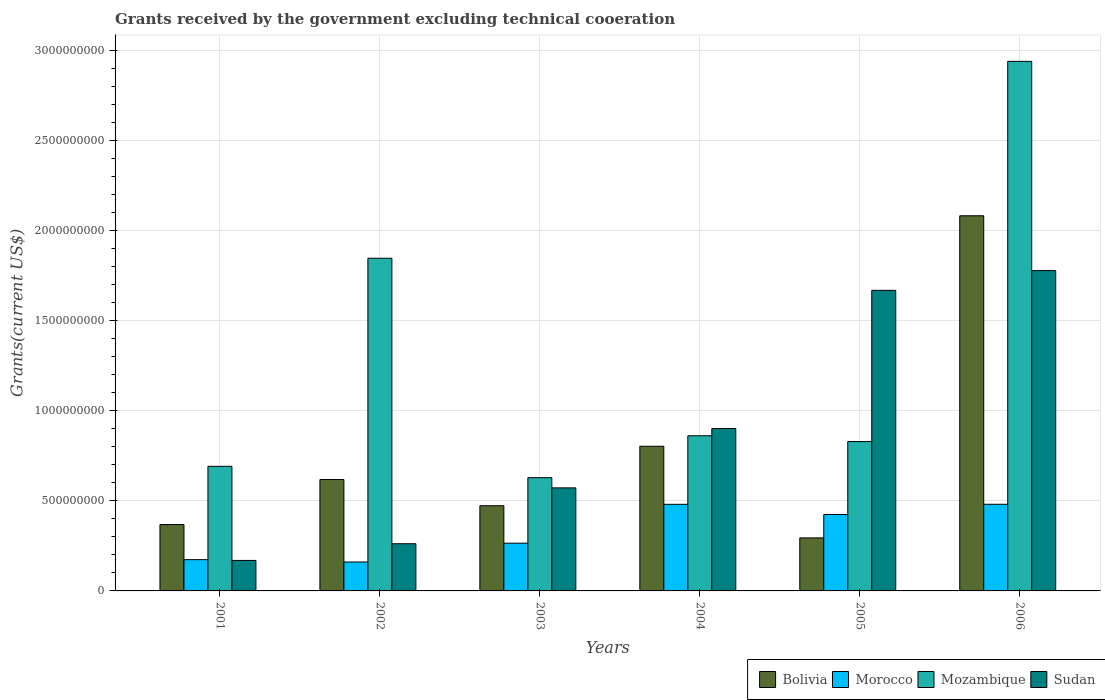How many groups of bars are there?
Your answer should be compact. 6. Are the number of bars on each tick of the X-axis equal?
Your answer should be compact. Yes. How many bars are there on the 4th tick from the right?
Provide a short and direct response. 4. What is the label of the 1st group of bars from the left?
Provide a succinct answer. 2001. In how many cases, is the number of bars for a given year not equal to the number of legend labels?
Provide a short and direct response. 0. What is the total grants received by the government in Sudan in 2005?
Give a very brief answer. 1.67e+09. Across all years, what is the maximum total grants received by the government in Mozambique?
Give a very brief answer. 2.94e+09. Across all years, what is the minimum total grants received by the government in Mozambique?
Offer a terse response. 6.28e+08. What is the total total grants received by the government in Bolivia in the graph?
Your answer should be compact. 4.64e+09. What is the difference between the total grants received by the government in Sudan in 2004 and that in 2005?
Offer a terse response. -7.67e+08. What is the difference between the total grants received by the government in Sudan in 2005 and the total grants received by the government in Mozambique in 2001?
Make the answer very short. 9.76e+08. What is the average total grants received by the government in Sudan per year?
Offer a very short reply. 8.91e+08. In the year 2003, what is the difference between the total grants received by the government in Bolivia and total grants received by the government in Sudan?
Your answer should be compact. -9.91e+07. In how many years, is the total grants received by the government in Mozambique greater than 900000000 US$?
Make the answer very short. 2. What is the ratio of the total grants received by the government in Sudan in 2002 to that in 2004?
Make the answer very short. 0.29. Is the total grants received by the government in Mozambique in 2001 less than that in 2002?
Provide a short and direct response. Yes. What is the difference between the highest and the second highest total grants received by the government in Mozambique?
Offer a very short reply. 1.09e+09. What is the difference between the highest and the lowest total grants received by the government in Mozambique?
Give a very brief answer. 2.31e+09. In how many years, is the total grants received by the government in Morocco greater than the average total grants received by the government in Morocco taken over all years?
Make the answer very short. 3. Is the sum of the total grants received by the government in Sudan in 2001 and 2003 greater than the maximum total grants received by the government in Mozambique across all years?
Provide a short and direct response. No. What does the 2nd bar from the left in 2006 represents?
Provide a short and direct response. Morocco. What does the 3rd bar from the right in 2002 represents?
Make the answer very short. Morocco. Is it the case that in every year, the sum of the total grants received by the government in Morocco and total grants received by the government in Mozambique is greater than the total grants received by the government in Sudan?
Keep it short and to the point. No. How many bars are there?
Provide a short and direct response. 24. How many years are there in the graph?
Your answer should be very brief. 6. Does the graph contain grids?
Provide a succinct answer. Yes. Where does the legend appear in the graph?
Your answer should be very brief. Bottom right. How many legend labels are there?
Offer a terse response. 4. How are the legend labels stacked?
Your answer should be very brief. Horizontal. What is the title of the graph?
Your answer should be very brief. Grants received by the government excluding technical cooeration. Does "Senegal" appear as one of the legend labels in the graph?
Keep it short and to the point. No. What is the label or title of the X-axis?
Your answer should be very brief. Years. What is the label or title of the Y-axis?
Give a very brief answer. Grants(current US$). What is the Grants(current US$) of Bolivia in 2001?
Your answer should be compact. 3.68e+08. What is the Grants(current US$) of Morocco in 2001?
Offer a terse response. 1.73e+08. What is the Grants(current US$) of Mozambique in 2001?
Provide a succinct answer. 6.91e+08. What is the Grants(current US$) of Sudan in 2001?
Your answer should be very brief. 1.69e+08. What is the Grants(current US$) in Bolivia in 2002?
Your answer should be very brief. 6.18e+08. What is the Grants(current US$) of Morocco in 2002?
Provide a short and direct response. 1.60e+08. What is the Grants(current US$) in Mozambique in 2002?
Offer a very short reply. 1.85e+09. What is the Grants(current US$) of Sudan in 2002?
Your answer should be very brief. 2.62e+08. What is the Grants(current US$) in Bolivia in 2003?
Offer a terse response. 4.73e+08. What is the Grants(current US$) of Morocco in 2003?
Give a very brief answer. 2.65e+08. What is the Grants(current US$) of Mozambique in 2003?
Provide a short and direct response. 6.28e+08. What is the Grants(current US$) in Sudan in 2003?
Make the answer very short. 5.72e+08. What is the Grants(current US$) in Bolivia in 2004?
Offer a terse response. 8.03e+08. What is the Grants(current US$) in Morocco in 2004?
Make the answer very short. 4.80e+08. What is the Grants(current US$) in Mozambique in 2004?
Make the answer very short. 8.61e+08. What is the Grants(current US$) in Sudan in 2004?
Provide a short and direct response. 9.01e+08. What is the Grants(current US$) of Bolivia in 2005?
Keep it short and to the point. 2.94e+08. What is the Grants(current US$) of Morocco in 2005?
Offer a terse response. 4.24e+08. What is the Grants(current US$) in Mozambique in 2005?
Your response must be concise. 8.29e+08. What is the Grants(current US$) in Sudan in 2005?
Your answer should be very brief. 1.67e+09. What is the Grants(current US$) in Bolivia in 2006?
Offer a terse response. 2.08e+09. What is the Grants(current US$) in Morocco in 2006?
Your answer should be very brief. 4.81e+08. What is the Grants(current US$) in Mozambique in 2006?
Offer a terse response. 2.94e+09. What is the Grants(current US$) in Sudan in 2006?
Ensure brevity in your answer.  1.78e+09. Across all years, what is the maximum Grants(current US$) of Bolivia?
Keep it short and to the point. 2.08e+09. Across all years, what is the maximum Grants(current US$) in Morocco?
Give a very brief answer. 4.81e+08. Across all years, what is the maximum Grants(current US$) in Mozambique?
Offer a very short reply. 2.94e+09. Across all years, what is the maximum Grants(current US$) in Sudan?
Offer a very short reply. 1.78e+09. Across all years, what is the minimum Grants(current US$) in Bolivia?
Offer a very short reply. 2.94e+08. Across all years, what is the minimum Grants(current US$) of Morocco?
Your answer should be compact. 1.60e+08. Across all years, what is the minimum Grants(current US$) of Mozambique?
Make the answer very short. 6.28e+08. Across all years, what is the minimum Grants(current US$) in Sudan?
Your response must be concise. 1.69e+08. What is the total Grants(current US$) of Bolivia in the graph?
Offer a very short reply. 4.64e+09. What is the total Grants(current US$) of Morocco in the graph?
Your response must be concise. 1.98e+09. What is the total Grants(current US$) of Mozambique in the graph?
Offer a terse response. 7.79e+09. What is the total Grants(current US$) in Sudan in the graph?
Your answer should be compact. 5.35e+09. What is the difference between the Grants(current US$) in Bolivia in 2001 and that in 2002?
Your response must be concise. -2.50e+08. What is the difference between the Grants(current US$) in Morocco in 2001 and that in 2002?
Your answer should be compact. 1.30e+07. What is the difference between the Grants(current US$) in Mozambique in 2001 and that in 2002?
Offer a terse response. -1.15e+09. What is the difference between the Grants(current US$) in Sudan in 2001 and that in 2002?
Ensure brevity in your answer.  -9.25e+07. What is the difference between the Grants(current US$) in Bolivia in 2001 and that in 2003?
Keep it short and to the point. -1.05e+08. What is the difference between the Grants(current US$) of Morocco in 2001 and that in 2003?
Provide a short and direct response. -9.14e+07. What is the difference between the Grants(current US$) of Mozambique in 2001 and that in 2003?
Offer a very short reply. 6.31e+07. What is the difference between the Grants(current US$) of Sudan in 2001 and that in 2003?
Give a very brief answer. -4.03e+08. What is the difference between the Grants(current US$) in Bolivia in 2001 and that in 2004?
Offer a terse response. -4.34e+08. What is the difference between the Grants(current US$) of Morocco in 2001 and that in 2004?
Keep it short and to the point. -3.07e+08. What is the difference between the Grants(current US$) of Mozambique in 2001 and that in 2004?
Make the answer very short. -1.70e+08. What is the difference between the Grants(current US$) of Sudan in 2001 and that in 2004?
Offer a very short reply. -7.32e+08. What is the difference between the Grants(current US$) in Bolivia in 2001 and that in 2005?
Your answer should be very brief. 7.40e+07. What is the difference between the Grants(current US$) of Morocco in 2001 and that in 2005?
Give a very brief answer. -2.51e+08. What is the difference between the Grants(current US$) of Mozambique in 2001 and that in 2005?
Give a very brief answer. -1.37e+08. What is the difference between the Grants(current US$) in Sudan in 2001 and that in 2005?
Give a very brief answer. -1.50e+09. What is the difference between the Grants(current US$) in Bolivia in 2001 and that in 2006?
Your answer should be very brief. -1.71e+09. What is the difference between the Grants(current US$) of Morocco in 2001 and that in 2006?
Offer a terse response. -3.07e+08. What is the difference between the Grants(current US$) in Mozambique in 2001 and that in 2006?
Give a very brief answer. -2.25e+09. What is the difference between the Grants(current US$) in Sudan in 2001 and that in 2006?
Offer a very short reply. -1.61e+09. What is the difference between the Grants(current US$) of Bolivia in 2002 and that in 2003?
Keep it short and to the point. 1.45e+08. What is the difference between the Grants(current US$) of Morocco in 2002 and that in 2003?
Offer a terse response. -1.04e+08. What is the difference between the Grants(current US$) of Mozambique in 2002 and that in 2003?
Provide a short and direct response. 1.22e+09. What is the difference between the Grants(current US$) of Sudan in 2002 and that in 2003?
Give a very brief answer. -3.10e+08. What is the difference between the Grants(current US$) in Bolivia in 2002 and that in 2004?
Offer a terse response. -1.85e+08. What is the difference between the Grants(current US$) in Morocco in 2002 and that in 2004?
Your response must be concise. -3.20e+08. What is the difference between the Grants(current US$) of Mozambique in 2002 and that in 2004?
Offer a very short reply. 9.85e+08. What is the difference between the Grants(current US$) of Sudan in 2002 and that in 2004?
Provide a short and direct response. -6.39e+08. What is the difference between the Grants(current US$) in Bolivia in 2002 and that in 2005?
Offer a terse response. 3.24e+08. What is the difference between the Grants(current US$) of Morocco in 2002 and that in 2005?
Offer a very short reply. -2.64e+08. What is the difference between the Grants(current US$) in Mozambique in 2002 and that in 2005?
Your answer should be very brief. 1.02e+09. What is the difference between the Grants(current US$) of Sudan in 2002 and that in 2005?
Give a very brief answer. -1.41e+09. What is the difference between the Grants(current US$) of Bolivia in 2002 and that in 2006?
Ensure brevity in your answer.  -1.46e+09. What is the difference between the Grants(current US$) in Morocco in 2002 and that in 2006?
Provide a short and direct response. -3.20e+08. What is the difference between the Grants(current US$) in Mozambique in 2002 and that in 2006?
Keep it short and to the point. -1.09e+09. What is the difference between the Grants(current US$) of Sudan in 2002 and that in 2006?
Keep it short and to the point. -1.52e+09. What is the difference between the Grants(current US$) in Bolivia in 2003 and that in 2004?
Give a very brief answer. -3.30e+08. What is the difference between the Grants(current US$) of Morocco in 2003 and that in 2004?
Your answer should be compact. -2.16e+08. What is the difference between the Grants(current US$) in Mozambique in 2003 and that in 2004?
Keep it short and to the point. -2.33e+08. What is the difference between the Grants(current US$) in Sudan in 2003 and that in 2004?
Keep it short and to the point. -3.29e+08. What is the difference between the Grants(current US$) of Bolivia in 2003 and that in 2005?
Your answer should be compact. 1.79e+08. What is the difference between the Grants(current US$) in Morocco in 2003 and that in 2005?
Offer a very short reply. -1.59e+08. What is the difference between the Grants(current US$) in Mozambique in 2003 and that in 2005?
Offer a terse response. -2.01e+08. What is the difference between the Grants(current US$) in Sudan in 2003 and that in 2005?
Provide a succinct answer. -1.10e+09. What is the difference between the Grants(current US$) in Bolivia in 2003 and that in 2006?
Give a very brief answer. -1.61e+09. What is the difference between the Grants(current US$) in Morocco in 2003 and that in 2006?
Your response must be concise. -2.16e+08. What is the difference between the Grants(current US$) in Mozambique in 2003 and that in 2006?
Offer a terse response. -2.31e+09. What is the difference between the Grants(current US$) in Sudan in 2003 and that in 2006?
Offer a terse response. -1.21e+09. What is the difference between the Grants(current US$) of Bolivia in 2004 and that in 2005?
Offer a terse response. 5.08e+08. What is the difference between the Grants(current US$) of Morocco in 2004 and that in 2005?
Make the answer very short. 5.65e+07. What is the difference between the Grants(current US$) of Mozambique in 2004 and that in 2005?
Offer a terse response. 3.22e+07. What is the difference between the Grants(current US$) of Sudan in 2004 and that in 2005?
Ensure brevity in your answer.  -7.67e+08. What is the difference between the Grants(current US$) of Bolivia in 2004 and that in 2006?
Make the answer very short. -1.28e+09. What is the difference between the Grants(current US$) in Mozambique in 2004 and that in 2006?
Your answer should be compact. -2.08e+09. What is the difference between the Grants(current US$) in Sudan in 2004 and that in 2006?
Ensure brevity in your answer.  -8.76e+08. What is the difference between the Grants(current US$) in Bolivia in 2005 and that in 2006?
Provide a short and direct response. -1.79e+09. What is the difference between the Grants(current US$) in Morocco in 2005 and that in 2006?
Your response must be concise. -5.67e+07. What is the difference between the Grants(current US$) of Mozambique in 2005 and that in 2006?
Ensure brevity in your answer.  -2.11e+09. What is the difference between the Grants(current US$) of Sudan in 2005 and that in 2006?
Offer a terse response. -1.10e+08. What is the difference between the Grants(current US$) of Bolivia in 2001 and the Grants(current US$) of Morocco in 2002?
Ensure brevity in your answer.  2.08e+08. What is the difference between the Grants(current US$) of Bolivia in 2001 and the Grants(current US$) of Mozambique in 2002?
Offer a terse response. -1.48e+09. What is the difference between the Grants(current US$) in Bolivia in 2001 and the Grants(current US$) in Sudan in 2002?
Keep it short and to the point. 1.06e+08. What is the difference between the Grants(current US$) in Morocco in 2001 and the Grants(current US$) in Mozambique in 2002?
Your answer should be very brief. -1.67e+09. What is the difference between the Grants(current US$) of Morocco in 2001 and the Grants(current US$) of Sudan in 2002?
Your answer should be compact. -8.83e+07. What is the difference between the Grants(current US$) of Mozambique in 2001 and the Grants(current US$) of Sudan in 2002?
Make the answer very short. 4.30e+08. What is the difference between the Grants(current US$) in Bolivia in 2001 and the Grants(current US$) in Morocco in 2003?
Your answer should be compact. 1.03e+08. What is the difference between the Grants(current US$) of Bolivia in 2001 and the Grants(current US$) of Mozambique in 2003?
Your response must be concise. -2.60e+08. What is the difference between the Grants(current US$) of Bolivia in 2001 and the Grants(current US$) of Sudan in 2003?
Offer a very short reply. -2.04e+08. What is the difference between the Grants(current US$) of Morocco in 2001 and the Grants(current US$) of Mozambique in 2003?
Give a very brief answer. -4.55e+08. What is the difference between the Grants(current US$) of Morocco in 2001 and the Grants(current US$) of Sudan in 2003?
Your answer should be compact. -3.98e+08. What is the difference between the Grants(current US$) of Mozambique in 2001 and the Grants(current US$) of Sudan in 2003?
Keep it short and to the point. 1.20e+08. What is the difference between the Grants(current US$) of Bolivia in 2001 and the Grants(current US$) of Morocco in 2004?
Offer a terse response. -1.12e+08. What is the difference between the Grants(current US$) of Bolivia in 2001 and the Grants(current US$) of Mozambique in 2004?
Provide a short and direct response. -4.93e+08. What is the difference between the Grants(current US$) in Bolivia in 2001 and the Grants(current US$) in Sudan in 2004?
Your answer should be compact. -5.33e+08. What is the difference between the Grants(current US$) in Morocco in 2001 and the Grants(current US$) in Mozambique in 2004?
Offer a terse response. -6.88e+08. What is the difference between the Grants(current US$) of Morocco in 2001 and the Grants(current US$) of Sudan in 2004?
Provide a succinct answer. -7.27e+08. What is the difference between the Grants(current US$) in Mozambique in 2001 and the Grants(current US$) in Sudan in 2004?
Your response must be concise. -2.10e+08. What is the difference between the Grants(current US$) in Bolivia in 2001 and the Grants(current US$) in Morocco in 2005?
Ensure brevity in your answer.  -5.58e+07. What is the difference between the Grants(current US$) of Bolivia in 2001 and the Grants(current US$) of Mozambique in 2005?
Your answer should be compact. -4.61e+08. What is the difference between the Grants(current US$) of Bolivia in 2001 and the Grants(current US$) of Sudan in 2005?
Your answer should be very brief. -1.30e+09. What is the difference between the Grants(current US$) in Morocco in 2001 and the Grants(current US$) in Mozambique in 2005?
Provide a short and direct response. -6.55e+08. What is the difference between the Grants(current US$) in Morocco in 2001 and the Grants(current US$) in Sudan in 2005?
Provide a short and direct response. -1.49e+09. What is the difference between the Grants(current US$) of Mozambique in 2001 and the Grants(current US$) of Sudan in 2005?
Offer a terse response. -9.76e+08. What is the difference between the Grants(current US$) in Bolivia in 2001 and the Grants(current US$) in Morocco in 2006?
Provide a succinct answer. -1.13e+08. What is the difference between the Grants(current US$) of Bolivia in 2001 and the Grants(current US$) of Mozambique in 2006?
Provide a short and direct response. -2.57e+09. What is the difference between the Grants(current US$) in Bolivia in 2001 and the Grants(current US$) in Sudan in 2006?
Give a very brief answer. -1.41e+09. What is the difference between the Grants(current US$) in Morocco in 2001 and the Grants(current US$) in Mozambique in 2006?
Ensure brevity in your answer.  -2.76e+09. What is the difference between the Grants(current US$) in Morocco in 2001 and the Grants(current US$) in Sudan in 2006?
Ensure brevity in your answer.  -1.60e+09. What is the difference between the Grants(current US$) of Mozambique in 2001 and the Grants(current US$) of Sudan in 2006?
Offer a very short reply. -1.09e+09. What is the difference between the Grants(current US$) of Bolivia in 2002 and the Grants(current US$) of Morocco in 2003?
Your response must be concise. 3.53e+08. What is the difference between the Grants(current US$) of Bolivia in 2002 and the Grants(current US$) of Mozambique in 2003?
Give a very brief answer. -1.02e+07. What is the difference between the Grants(current US$) in Bolivia in 2002 and the Grants(current US$) in Sudan in 2003?
Offer a terse response. 4.62e+07. What is the difference between the Grants(current US$) of Morocco in 2002 and the Grants(current US$) of Mozambique in 2003?
Your answer should be very brief. -4.68e+08. What is the difference between the Grants(current US$) in Morocco in 2002 and the Grants(current US$) in Sudan in 2003?
Your response must be concise. -4.11e+08. What is the difference between the Grants(current US$) of Mozambique in 2002 and the Grants(current US$) of Sudan in 2003?
Your answer should be compact. 1.27e+09. What is the difference between the Grants(current US$) in Bolivia in 2002 and the Grants(current US$) in Morocco in 2004?
Offer a very short reply. 1.37e+08. What is the difference between the Grants(current US$) in Bolivia in 2002 and the Grants(current US$) in Mozambique in 2004?
Your answer should be very brief. -2.43e+08. What is the difference between the Grants(current US$) of Bolivia in 2002 and the Grants(current US$) of Sudan in 2004?
Give a very brief answer. -2.83e+08. What is the difference between the Grants(current US$) of Morocco in 2002 and the Grants(current US$) of Mozambique in 2004?
Keep it short and to the point. -7.00e+08. What is the difference between the Grants(current US$) in Morocco in 2002 and the Grants(current US$) in Sudan in 2004?
Offer a terse response. -7.40e+08. What is the difference between the Grants(current US$) in Mozambique in 2002 and the Grants(current US$) in Sudan in 2004?
Keep it short and to the point. 9.45e+08. What is the difference between the Grants(current US$) in Bolivia in 2002 and the Grants(current US$) in Morocco in 2005?
Make the answer very short. 1.94e+08. What is the difference between the Grants(current US$) of Bolivia in 2002 and the Grants(current US$) of Mozambique in 2005?
Your answer should be very brief. -2.11e+08. What is the difference between the Grants(current US$) in Bolivia in 2002 and the Grants(current US$) in Sudan in 2005?
Ensure brevity in your answer.  -1.05e+09. What is the difference between the Grants(current US$) in Morocco in 2002 and the Grants(current US$) in Mozambique in 2005?
Your response must be concise. -6.68e+08. What is the difference between the Grants(current US$) of Morocco in 2002 and the Grants(current US$) of Sudan in 2005?
Offer a very short reply. -1.51e+09. What is the difference between the Grants(current US$) of Mozambique in 2002 and the Grants(current US$) of Sudan in 2005?
Your response must be concise. 1.78e+08. What is the difference between the Grants(current US$) of Bolivia in 2002 and the Grants(current US$) of Morocco in 2006?
Offer a very short reply. 1.37e+08. What is the difference between the Grants(current US$) in Bolivia in 2002 and the Grants(current US$) in Mozambique in 2006?
Provide a short and direct response. -2.32e+09. What is the difference between the Grants(current US$) in Bolivia in 2002 and the Grants(current US$) in Sudan in 2006?
Offer a terse response. -1.16e+09. What is the difference between the Grants(current US$) of Morocco in 2002 and the Grants(current US$) of Mozambique in 2006?
Your answer should be very brief. -2.78e+09. What is the difference between the Grants(current US$) in Morocco in 2002 and the Grants(current US$) in Sudan in 2006?
Offer a terse response. -1.62e+09. What is the difference between the Grants(current US$) in Mozambique in 2002 and the Grants(current US$) in Sudan in 2006?
Your answer should be very brief. 6.85e+07. What is the difference between the Grants(current US$) of Bolivia in 2003 and the Grants(current US$) of Morocco in 2004?
Keep it short and to the point. -7.77e+06. What is the difference between the Grants(current US$) in Bolivia in 2003 and the Grants(current US$) in Mozambique in 2004?
Your answer should be compact. -3.88e+08. What is the difference between the Grants(current US$) of Bolivia in 2003 and the Grants(current US$) of Sudan in 2004?
Make the answer very short. -4.28e+08. What is the difference between the Grants(current US$) in Morocco in 2003 and the Grants(current US$) in Mozambique in 2004?
Ensure brevity in your answer.  -5.96e+08. What is the difference between the Grants(current US$) of Morocco in 2003 and the Grants(current US$) of Sudan in 2004?
Make the answer very short. -6.36e+08. What is the difference between the Grants(current US$) in Mozambique in 2003 and the Grants(current US$) in Sudan in 2004?
Provide a short and direct response. -2.73e+08. What is the difference between the Grants(current US$) in Bolivia in 2003 and the Grants(current US$) in Morocco in 2005?
Make the answer very short. 4.87e+07. What is the difference between the Grants(current US$) in Bolivia in 2003 and the Grants(current US$) in Mozambique in 2005?
Make the answer very short. -3.56e+08. What is the difference between the Grants(current US$) in Bolivia in 2003 and the Grants(current US$) in Sudan in 2005?
Your response must be concise. -1.19e+09. What is the difference between the Grants(current US$) in Morocco in 2003 and the Grants(current US$) in Mozambique in 2005?
Provide a succinct answer. -5.64e+08. What is the difference between the Grants(current US$) in Morocco in 2003 and the Grants(current US$) in Sudan in 2005?
Your answer should be compact. -1.40e+09. What is the difference between the Grants(current US$) of Mozambique in 2003 and the Grants(current US$) of Sudan in 2005?
Your answer should be very brief. -1.04e+09. What is the difference between the Grants(current US$) of Bolivia in 2003 and the Grants(current US$) of Morocco in 2006?
Provide a succinct answer. -8.01e+06. What is the difference between the Grants(current US$) of Bolivia in 2003 and the Grants(current US$) of Mozambique in 2006?
Keep it short and to the point. -2.47e+09. What is the difference between the Grants(current US$) in Bolivia in 2003 and the Grants(current US$) in Sudan in 2006?
Your answer should be compact. -1.30e+09. What is the difference between the Grants(current US$) in Morocco in 2003 and the Grants(current US$) in Mozambique in 2006?
Offer a terse response. -2.67e+09. What is the difference between the Grants(current US$) in Morocco in 2003 and the Grants(current US$) in Sudan in 2006?
Your response must be concise. -1.51e+09. What is the difference between the Grants(current US$) in Mozambique in 2003 and the Grants(current US$) in Sudan in 2006?
Your answer should be very brief. -1.15e+09. What is the difference between the Grants(current US$) in Bolivia in 2004 and the Grants(current US$) in Morocco in 2005?
Provide a succinct answer. 3.79e+08. What is the difference between the Grants(current US$) of Bolivia in 2004 and the Grants(current US$) of Mozambique in 2005?
Your response must be concise. -2.61e+07. What is the difference between the Grants(current US$) in Bolivia in 2004 and the Grants(current US$) in Sudan in 2005?
Ensure brevity in your answer.  -8.65e+08. What is the difference between the Grants(current US$) in Morocco in 2004 and the Grants(current US$) in Mozambique in 2005?
Your answer should be very brief. -3.48e+08. What is the difference between the Grants(current US$) of Morocco in 2004 and the Grants(current US$) of Sudan in 2005?
Offer a terse response. -1.19e+09. What is the difference between the Grants(current US$) of Mozambique in 2004 and the Grants(current US$) of Sudan in 2005?
Provide a succinct answer. -8.07e+08. What is the difference between the Grants(current US$) in Bolivia in 2004 and the Grants(current US$) in Morocco in 2006?
Keep it short and to the point. 3.22e+08. What is the difference between the Grants(current US$) of Bolivia in 2004 and the Grants(current US$) of Mozambique in 2006?
Your response must be concise. -2.14e+09. What is the difference between the Grants(current US$) of Bolivia in 2004 and the Grants(current US$) of Sudan in 2006?
Your answer should be compact. -9.75e+08. What is the difference between the Grants(current US$) in Morocco in 2004 and the Grants(current US$) in Mozambique in 2006?
Make the answer very short. -2.46e+09. What is the difference between the Grants(current US$) in Morocco in 2004 and the Grants(current US$) in Sudan in 2006?
Offer a very short reply. -1.30e+09. What is the difference between the Grants(current US$) in Mozambique in 2004 and the Grants(current US$) in Sudan in 2006?
Provide a succinct answer. -9.16e+08. What is the difference between the Grants(current US$) of Bolivia in 2005 and the Grants(current US$) of Morocco in 2006?
Ensure brevity in your answer.  -1.87e+08. What is the difference between the Grants(current US$) in Bolivia in 2005 and the Grants(current US$) in Mozambique in 2006?
Make the answer very short. -2.64e+09. What is the difference between the Grants(current US$) in Bolivia in 2005 and the Grants(current US$) in Sudan in 2006?
Make the answer very short. -1.48e+09. What is the difference between the Grants(current US$) of Morocco in 2005 and the Grants(current US$) of Mozambique in 2006?
Give a very brief answer. -2.51e+09. What is the difference between the Grants(current US$) of Morocco in 2005 and the Grants(current US$) of Sudan in 2006?
Your answer should be compact. -1.35e+09. What is the difference between the Grants(current US$) of Mozambique in 2005 and the Grants(current US$) of Sudan in 2006?
Keep it short and to the point. -9.48e+08. What is the average Grants(current US$) of Bolivia per year?
Your response must be concise. 7.73e+08. What is the average Grants(current US$) of Morocco per year?
Make the answer very short. 3.31e+08. What is the average Grants(current US$) of Mozambique per year?
Your answer should be compact. 1.30e+09. What is the average Grants(current US$) of Sudan per year?
Your answer should be very brief. 8.91e+08. In the year 2001, what is the difference between the Grants(current US$) in Bolivia and Grants(current US$) in Morocco?
Give a very brief answer. 1.95e+08. In the year 2001, what is the difference between the Grants(current US$) in Bolivia and Grants(current US$) in Mozambique?
Ensure brevity in your answer.  -3.23e+08. In the year 2001, what is the difference between the Grants(current US$) of Bolivia and Grants(current US$) of Sudan?
Ensure brevity in your answer.  1.99e+08. In the year 2001, what is the difference between the Grants(current US$) in Morocco and Grants(current US$) in Mozambique?
Give a very brief answer. -5.18e+08. In the year 2001, what is the difference between the Grants(current US$) in Morocco and Grants(current US$) in Sudan?
Keep it short and to the point. 4.22e+06. In the year 2001, what is the difference between the Grants(current US$) in Mozambique and Grants(current US$) in Sudan?
Provide a succinct answer. 5.22e+08. In the year 2002, what is the difference between the Grants(current US$) in Bolivia and Grants(current US$) in Morocco?
Make the answer very short. 4.57e+08. In the year 2002, what is the difference between the Grants(current US$) of Bolivia and Grants(current US$) of Mozambique?
Your response must be concise. -1.23e+09. In the year 2002, what is the difference between the Grants(current US$) of Bolivia and Grants(current US$) of Sudan?
Keep it short and to the point. 3.56e+08. In the year 2002, what is the difference between the Grants(current US$) of Morocco and Grants(current US$) of Mozambique?
Offer a terse response. -1.69e+09. In the year 2002, what is the difference between the Grants(current US$) in Morocco and Grants(current US$) in Sudan?
Offer a terse response. -1.01e+08. In the year 2002, what is the difference between the Grants(current US$) in Mozambique and Grants(current US$) in Sudan?
Ensure brevity in your answer.  1.58e+09. In the year 2003, what is the difference between the Grants(current US$) of Bolivia and Grants(current US$) of Morocco?
Offer a terse response. 2.08e+08. In the year 2003, what is the difference between the Grants(current US$) of Bolivia and Grants(current US$) of Mozambique?
Give a very brief answer. -1.55e+08. In the year 2003, what is the difference between the Grants(current US$) in Bolivia and Grants(current US$) in Sudan?
Give a very brief answer. -9.91e+07. In the year 2003, what is the difference between the Grants(current US$) in Morocco and Grants(current US$) in Mozambique?
Keep it short and to the point. -3.63e+08. In the year 2003, what is the difference between the Grants(current US$) in Morocco and Grants(current US$) in Sudan?
Give a very brief answer. -3.07e+08. In the year 2003, what is the difference between the Grants(current US$) of Mozambique and Grants(current US$) of Sudan?
Your response must be concise. 5.64e+07. In the year 2004, what is the difference between the Grants(current US$) of Bolivia and Grants(current US$) of Morocco?
Provide a short and direct response. 3.22e+08. In the year 2004, what is the difference between the Grants(current US$) of Bolivia and Grants(current US$) of Mozambique?
Your answer should be compact. -5.83e+07. In the year 2004, what is the difference between the Grants(current US$) in Bolivia and Grants(current US$) in Sudan?
Offer a very short reply. -9.82e+07. In the year 2004, what is the difference between the Grants(current US$) in Morocco and Grants(current US$) in Mozambique?
Your answer should be very brief. -3.80e+08. In the year 2004, what is the difference between the Grants(current US$) of Morocco and Grants(current US$) of Sudan?
Your response must be concise. -4.20e+08. In the year 2004, what is the difference between the Grants(current US$) in Mozambique and Grants(current US$) in Sudan?
Offer a very short reply. -3.99e+07. In the year 2005, what is the difference between the Grants(current US$) in Bolivia and Grants(current US$) in Morocco?
Your answer should be very brief. -1.30e+08. In the year 2005, what is the difference between the Grants(current US$) in Bolivia and Grants(current US$) in Mozambique?
Your answer should be compact. -5.35e+08. In the year 2005, what is the difference between the Grants(current US$) in Bolivia and Grants(current US$) in Sudan?
Your answer should be very brief. -1.37e+09. In the year 2005, what is the difference between the Grants(current US$) of Morocco and Grants(current US$) of Mozambique?
Make the answer very short. -4.05e+08. In the year 2005, what is the difference between the Grants(current US$) in Morocco and Grants(current US$) in Sudan?
Offer a terse response. -1.24e+09. In the year 2005, what is the difference between the Grants(current US$) of Mozambique and Grants(current US$) of Sudan?
Your answer should be compact. -8.39e+08. In the year 2006, what is the difference between the Grants(current US$) in Bolivia and Grants(current US$) in Morocco?
Your answer should be compact. 1.60e+09. In the year 2006, what is the difference between the Grants(current US$) of Bolivia and Grants(current US$) of Mozambique?
Keep it short and to the point. -8.57e+08. In the year 2006, what is the difference between the Grants(current US$) of Bolivia and Grants(current US$) of Sudan?
Keep it short and to the point. 3.04e+08. In the year 2006, what is the difference between the Grants(current US$) of Morocco and Grants(current US$) of Mozambique?
Offer a very short reply. -2.46e+09. In the year 2006, what is the difference between the Grants(current US$) in Morocco and Grants(current US$) in Sudan?
Provide a short and direct response. -1.30e+09. In the year 2006, what is the difference between the Grants(current US$) in Mozambique and Grants(current US$) in Sudan?
Your answer should be compact. 1.16e+09. What is the ratio of the Grants(current US$) in Bolivia in 2001 to that in 2002?
Ensure brevity in your answer.  0.6. What is the ratio of the Grants(current US$) in Morocco in 2001 to that in 2002?
Give a very brief answer. 1.08. What is the ratio of the Grants(current US$) in Mozambique in 2001 to that in 2002?
Make the answer very short. 0.37. What is the ratio of the Grants(current US$) of Sudan in 2001 to that in 2002?
Keep it short and to the point. 0.65. What is the ratio of the Grants(current US$) in Bolivia in 2001 to that in 2003?
Give a very brief answer. 0.78. What is the ratio of the Grants(current US$) in Morocco in 2001 to that in 2003?
Give a very brief answer. 0.65. What is the ratio of the Grants(current US$) in Mozambique in 2001 to that in 2003?
Provide a succinct answer. 1.1. What is the ratio of the Grants(current US$) of Sudan in 2001 to that in 2003?
Provide a short and direct response. 0.3. What is the ratio of the Grants(current US$) in Bolivia in 2001 to that in 2004?
Provide a succinct answer. 0.46. What is the ratio of the Grants(current US$) in Morocco in 2001 to that in 2004?
Your response must be concise. 0.36. What is the ratio of the Grants(current US$) in Mozambique in 2001 to that in 2004?
Your response must be concise. 0.8. What is the ratio of the Grants(current US$) of Sudan in 2001 to that in 2004?
Ensure brevity in your answer.  0.19. What is the ratio of the Grants(current US$) in Bolivia in 2001 to that in 2005?
Your response must be concise. 1.25. What is the ratio of the Grants(current US$) in Morocco in 2001 to that in 2005?
Provide a succinct answer. 0.41. What is the ratio of the Grants(current US$) in Mozambique in 2001 to that in 2005?
Your response must be concise. 0.83. What is the ratio of the Grants(current US$) of Sudan in 2001 to that in 2005?
Keep it short and to the point. 0.1. What is the ratio of the Grants(current US$) of Bolivia in 2001 to that in 2006?
Offer a very short reply. 0.18. What is the ratio of the Grants(current US$) in Morocco in 2001 to that in 2006?
Your answer should be very brief. 0.36. What is the ratio of the Grants(current US$) in Mozambique in 2001 to that in 2006?
Keep it short and to the point. 0.24. What is the ratio of the Grants(current US$) in Sudan in 2001 to that in 2006?
Offer a very short reply. 0.1. What is the ratio of the Grants(current US$) in Bolivia in 2002 to that in 2003?
Give a very brief answer. 1.31. What is the ratio of the Grants(current US$) in Morocco in 2002 to that in 2003?
Offer a terse response. 0.61. What is the ratio of the Grants(current US$) of Mozambique in 2002 to that in 2003?
Keep it short and to the point. 2.94. What is the ratio of the Grants(current US$) of Sudan in 2002 to that in 2003?
Ensure brevity in your answer.  0.46. What is the ratio of the Grants(current US$) in Bolivia in 2002 to that in 2004?
Make the answer very short. 0.77. What is the ratio of the Grants(current US$) in Morocco in 2002 to that in 2004?
Provide a succinct answer. 0.33. What is the ratio of the Grants(current US$) of Mozambique in 2002 to that in 2004?
Offer a terse response. 2.14. What is the ratio of the Grants(current US$) in Sudan in 2002 to that in 2004?
Provide a short and direct response. 0.29. What is the ratio of the Grants(current US$) of Bolivia in 2002 to that in 2005?
Provide a short and direct response. 2.1. What is the ratio of the Grants(current US$) of Morocco in 2002 to that in 2005?
Ensure brevity in your answer.  0.38. What is the ratio of the Grants(current US$) of Mozambique in 2002 to that in 2005?
Provide a succinct answer. 2.23. What is the ratio of the Grants(current US$) of Sudan in 2002 to that in 2005?
Your answer should be very brief. 0.16. What is the ratio of the Grants(current US$) of Bolivia in 2002 to that in 2006?
Your answer should be very brief. 0.3. What is the ratio of the Grants(current US$) of Morocco in 2002 to that in 2006?
Ensure brevity in your answer.  0.33. What is the ratio of the Grants(current US$) in Mozambique in 2002 to that in 2006?
Give a very brief answer. 0.63. What is the ratio of the Grants(current US$) in Sudan in 2002 to that in 2006?
Ensure brevity in your answer.  0.15. What is the ratio of the Grants(current US$) in Bolivia in 2003 to that in 2004?
Give a very brief answer. 0.59. What is the ratio of the Grants(current US$) of Morocco in 2003 to that in 2004?
Your answer should be very brief. 0.55. What is the ratio of the Grants(current US$) in Mozambique in 2003 to that in 2004?
Your answer should be very brief. 0.73. What is the ratio of the Grants(current US$) in Sudan in 2003 to that in 2004?
Offer a very short reply. 0.63. What is the ratio of the Grants(current US$) in Bolivia in 2003 to that in 2005?
Provide a short and direct response. 1.61. What is the ratio of the Grants(current US$) of Morocco in 2003 to that in 2005?
Give a very brief answer. 0.62. What is the ratio of the Grants(current US$) of Mozambique in 2003 to that in 2005?
Make the answer very short. 0.76. What is the ratio of the Grants(current US$) of Sudan in 2003 to that in 2005?
Keep it short and to the point. 0.34. What is the ratio of the Grants(current US$) of Bolivia in 2003 to that in 2006?
Make the answer very short. 0.23. What is the ratio of the Grants(current US$) of Morocco in 2003 to that in 2006?
Provide a succinct answer. 0.55. What is the ratio of the Grants(current US$) in Mozambique in 2003 to that in 2006?
Offer a terse response. 0.21. What is the ratio of the Grants(current US$) in Sudan in 2003 to that in 2006?
Make the answer very short. 0.32. What is the ratio of the Grants(current US$) in Bolivia in 2004 to that in 2005?
Offer a very short reply. 2.73. What is the ratio of the Grants(current US$) of Morocco in 2004 to that in 2005?
Keep it short and to the point. 1.13. What is the ratio of the Grants(current US$) of Mozambique in 2004 to that in 2005?
Ensure brevity in your answer.  1.04. What is the ratio of the Grants(current US$) of Sudan in 2004 to that in 2005?
Keep it short and to the point. 0.54. What is the ratio of the Grants(current US$) in Bolivia in 2004 to that in 2006?
Provide a succinct answer. 0.39. What is the ratio of the Grants(current US$) in Morocco in 2004 to that in 2006?
Your answer should be compact. 1. What is the ratio of the Grants(current US$) in Mozambique in 2004 to that in 2006?
Give a very brief answer. 0.29. What is the ratio of the Grants(current US$) of Sudan in 2004 to that in 2006?
Keep it short and to the point. 0.51. What is the ratio of the Grants(current US$) of Bolivia in 2005 to that in 2006?
Offer a terse response. 0.14. What is the ratio of the Grants(current US$) of Morocco in 2005 to that in 2006?
Make the answer very short. 0.88. What is the ratio of the Grants(current US$) in Mozambique in 2005 to that in 2006?
Make the answer very short. 0.28. What is the ratio of the Grants(current US$) in Sudan in 2005 to that in 2006?
Keep it short and to the point. 0.94. What is the difference between the highest and the second highest Grants(current US$) in Bolivia?
Offer a terse response. 1.28e+09. What is the difference between the highest and the second highest Grants(current US$) in Morocco?
Provide a succinct answer. 2.40e+05. What is the difference between the highest and the second highest Grants(current US$) in Mozambique?
Give a very brief answer. 1.09e+09. What is the difference between the highest and the second highest Grants(current US$) in Sudan?
Make the answer very short. 1.10e+08. What is the difference between the highest and the lowest Grants(current US$) in Bolivia?
Your response must be concise. 1.79e+09. What is the difference between the highest and the lowest Grants(current US$) of Morocco?
Offer a very short reply. 3.20e+08. What is the difference between the highest and the lowest Grants(current US$) of Mozambique?
Provide a short and direct response. 2.31e+09. What is the difference between the highest and the lowest Grants(current US$) in Sudan?
Offer a very short reply. 1.61e+09. 